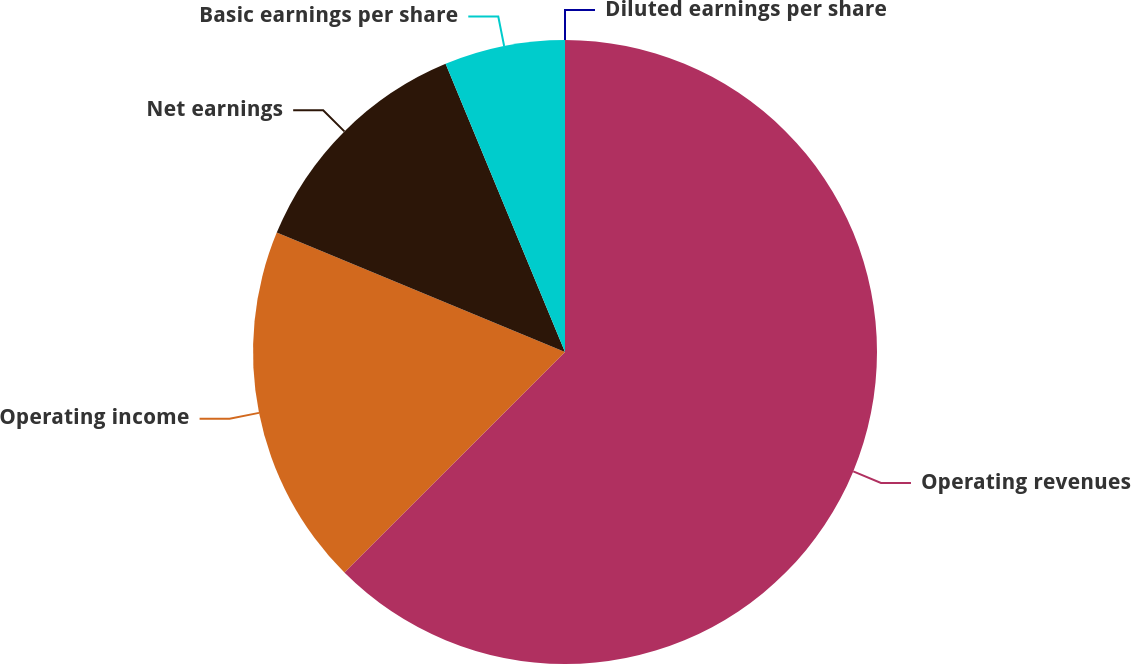Convert chart. <chart><loc_0><loc_0><loc_500><loc_500><pie_chart><fcel>Operating revenues<fcel>Operating income<fcel>Net earnings<fcel>Basic earnings per share<fcel>Diluted earnings per share<nl><fcel>62.5%<fcel>18.75%<fcel>12.5%<fcel>6.25%<fcel>0.0%<nl></chart> 